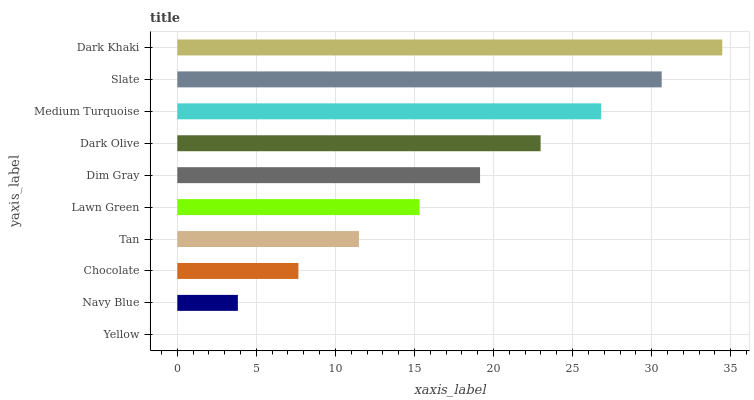Is Yellow the minimum?
Answer yes or no. Yes. Is Dark Khaki the maximum?
Answer yes or no. Yes. Is Navy Blue the minimum?
Answer yes or no. No. Is Navy Blue the maximum?
Answer yes or no. No. Is Navy Blue greater than Yellow?
Answer yes or no. Yes. Is Yellow less than Navy Blue?
Answer yes or no. Yes. Is Yellow greater than Navy Blue?
Answer yes or no. No. Is Navy Blue less than Yellow?
Answer yes or no. No. Is Dim Gray the high median?
Answer yes or no. Yes. Is Lawn Green the low median?
Answer yes or no. Yes. Is Dark Khaki the high median?
Answer yes or no. No. Is Dark Khaki the low median?
Answer yes or no. No. 